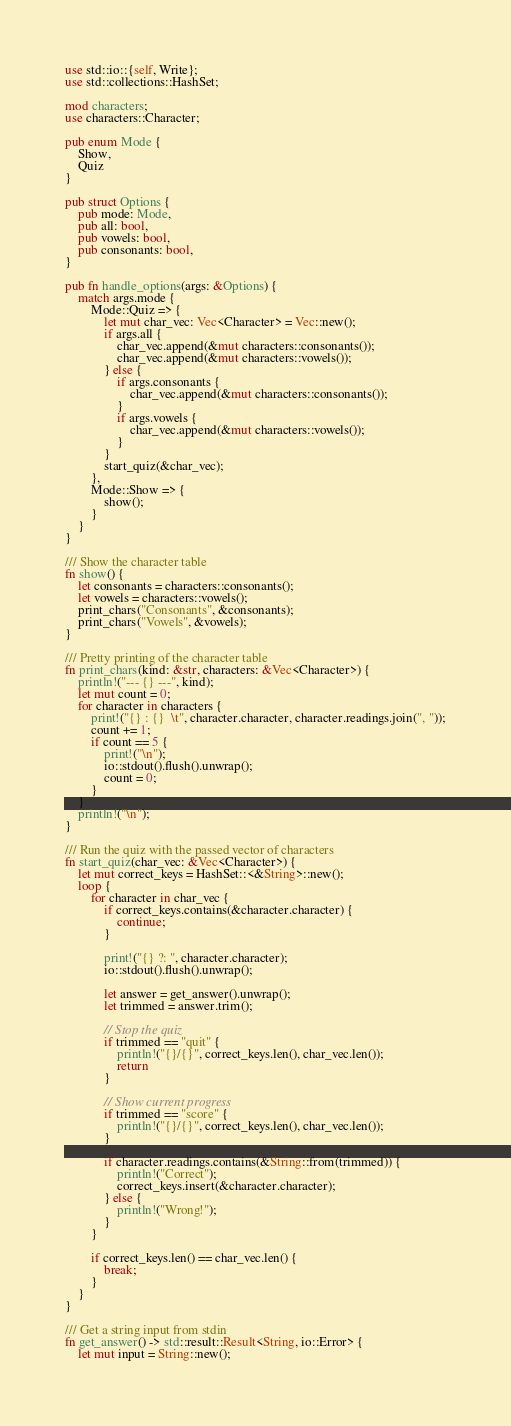Convert code to text. <code><loc_0><loc_0><loc_500><loc_500><_Rust_>use std::io::{self, Write};
use std::collections::HashSet;

mod characters;
use characters::Character;

pub enum Mode {
    Show,
    Quiz
}

pub struct Options {
    pub mode: Mode,
    pub all: bool,
    pub vowels: bool,
    pub consonants: bool,
}

pub fn handle_options(args: &Options) {
    match args.mode {
        Mode::Quiz => {
            let mut char_vec: Vec<Character> = Vec::new();
            if args.all {
                char_vec.append(&mut characters::consonants());
                char_vec.append(&mut characters::vowels());
            } else {
                if args.consonants {
                    char_vec.append(&mut characters::consonants());
                }
                if args.vowels {
                    char_vec.append(&mut characters::vowels()); 
                }
            }
            start_quiz(&char_vec);
        },
        Mode::Show => {
            show();
        }
    }
}

/// Show the character table
fn show() {
    let consonants = characters::consonants();
    let vowels = characters::vowels();
    print_chars("Consonants", &consonants);
    print_chars("Vowels", &vowels);
}

/// Pretty printing of the character table
fn print_chars(kind: &str, characters: &Vec<Character>) {
    println!("--- {} ---", kind);
    let mut count = 0;
    for character in characters {
        print!("{} : {}  \t", character.character, character.readings.join(", "));
        count += 1;
        if count == 5 {
            print!("\n");
            io::stdout().flush().unwrap();
            count = 0;
        }
    }
    println!("\n");
}

/// Run the quiz with the passed vector of characters
fn start_quiz(char_vec: &Vec<Character>) {
    let mut correct_keys = HashSet::<&String>::new();
    loop {
        for character in char_vec {
            if correct_keys.contains(&character.character) {
                continue;
            }

            print!("{} ?: ", character.character);
            io::stdout().flush().unwrap();
            
            let answer = get_answer().unwrap();
            let trimmed = answer.trim();

            // Stop the quiz
            if trimmed == "quit" {
                println!("{}/{}", correct_keys.len(), char_vec.len());
                return
            }

            // Show current progress
            if trimmed == "score" {
                println!("{}/{}", correct_keys.len(), char_vec.len());
            }

            if character.readings.contains(&String::from(trimmed)) {
                println!("Correct");
                correct_keys.insert(&character.character);
            } else {
                println!("Wrong!");
            }
        }

        if correct_keys.len() == char_vec.len() {
            break;
        }
    }
}

/// Get a string input from stdin
fn get_answer() -> std::result::Result<String, io::Error> {
    let mut input = String::new();</code> 